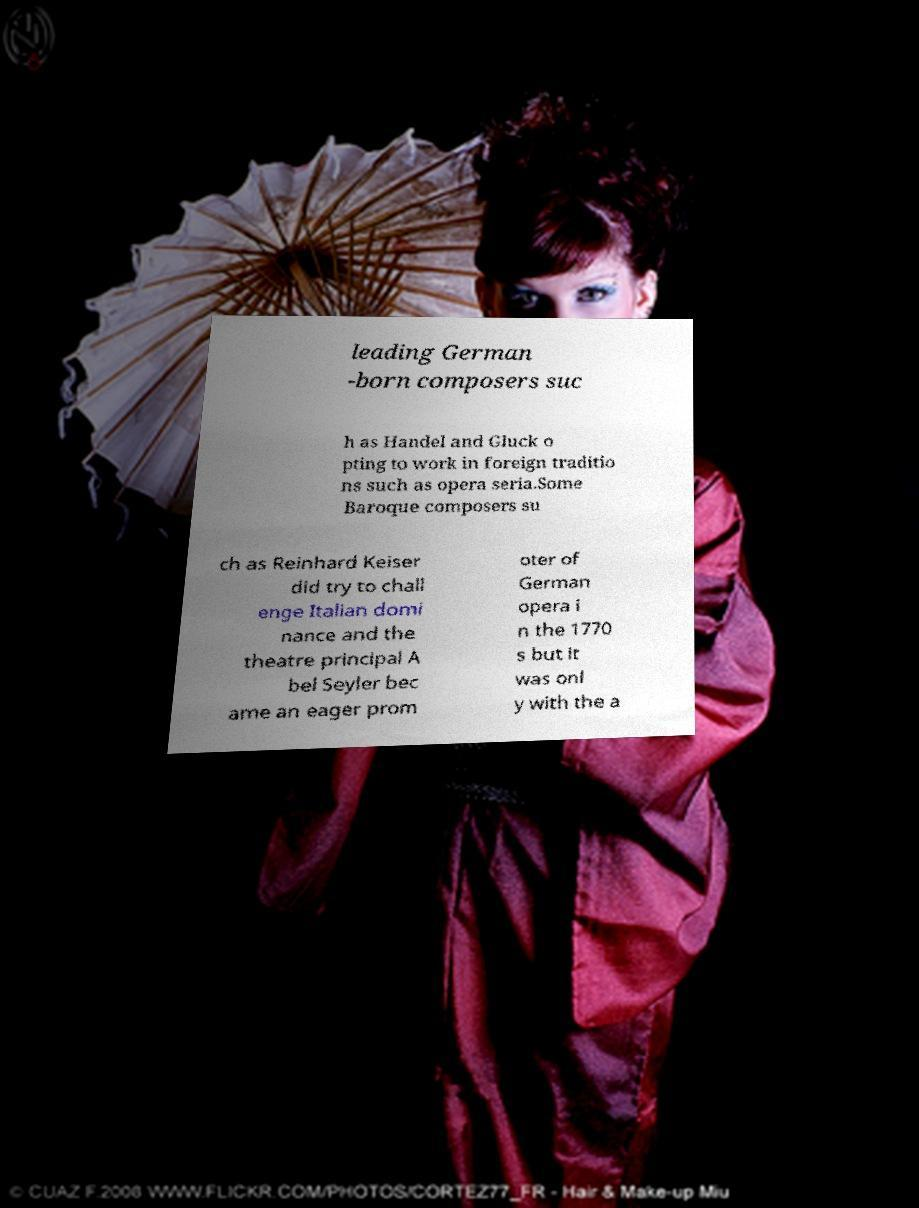Could you assist in decoding the text presented in this image and type it out clearly? leading German -born composers suc h as Handel and Gluck o pting to work in foreign traditio ns such as opera seria.Some Baroque composers su ch as Reinhard Keiser did try to chall enge Italian domi nance and the theatre principal A bel Seyler bec ame an eager prom oter of German opera i n the 1770 s but it was onl y with the a 